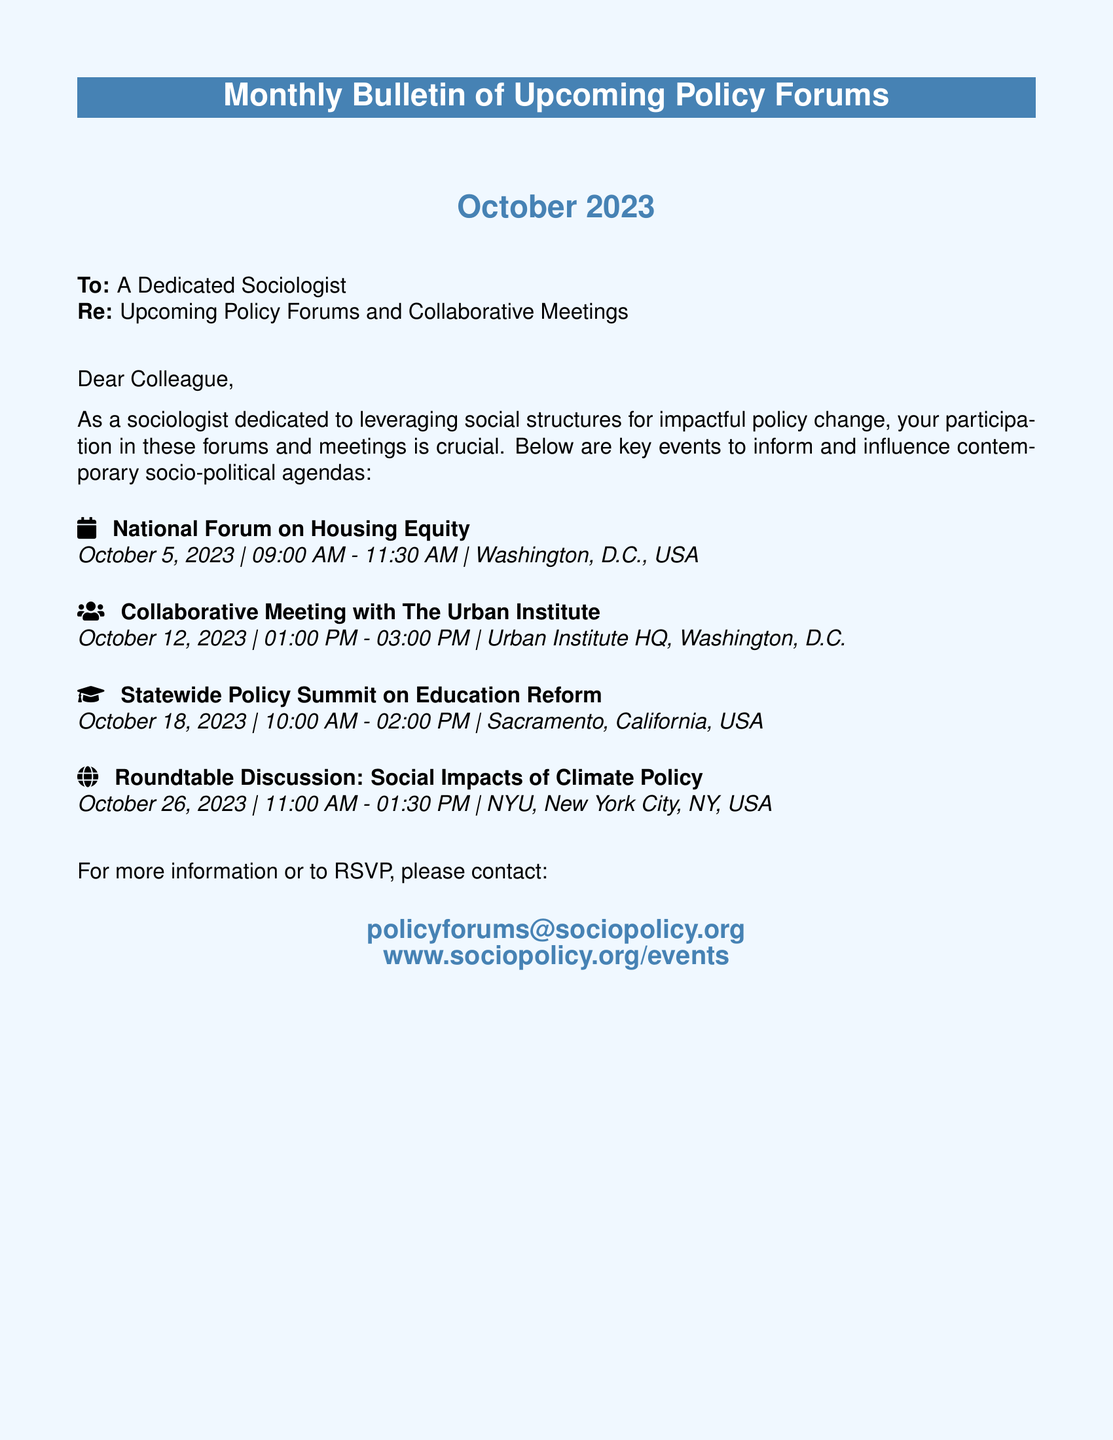what is the date of the National Forum on Housing Equity? The date is specified in the document as October 5, 2023.
Answer: October 5, 2023 what time does the Collaborative Meeting with The Urban Institute start? The starting time is provided in the document as 01:00 PM.
Answer: 01:00 PM where will the Statewide Policy Summit on Education Reform take place? The location is mentioned in the document as Sacramento, California, USA.
Answer: Sacramento, California, USA how long is the Roundtable Discussion on Social Impacts of Climate Policy? The document states the duration from 11:00 AM to 01:30 PM, totaling 2.5 hours.
Answer: 2.5 hours which organization is collaborating on the meeting scheduled for October 12, 2023? The collaborating organization is mentioned in the document as The Urban Institute.
Answer: The Urban Institute what is the main focus of the National Forum on Housing Equity? The focus is implied in the title, which pertains to Housing Equity.
Answer: Housing Equity how many events are listed in this bulletin? The document lists four distinct events.
Answer: Four who should be contacted for more information according to the document? The contact provided in the document is policyforums@sociopolicy.org.
Answer: policyforums@sociopolicy.org in what city is the Roundtable Discussion located? The city for the Roundtable Discussion is specified as New York City.
Answer: New York City 